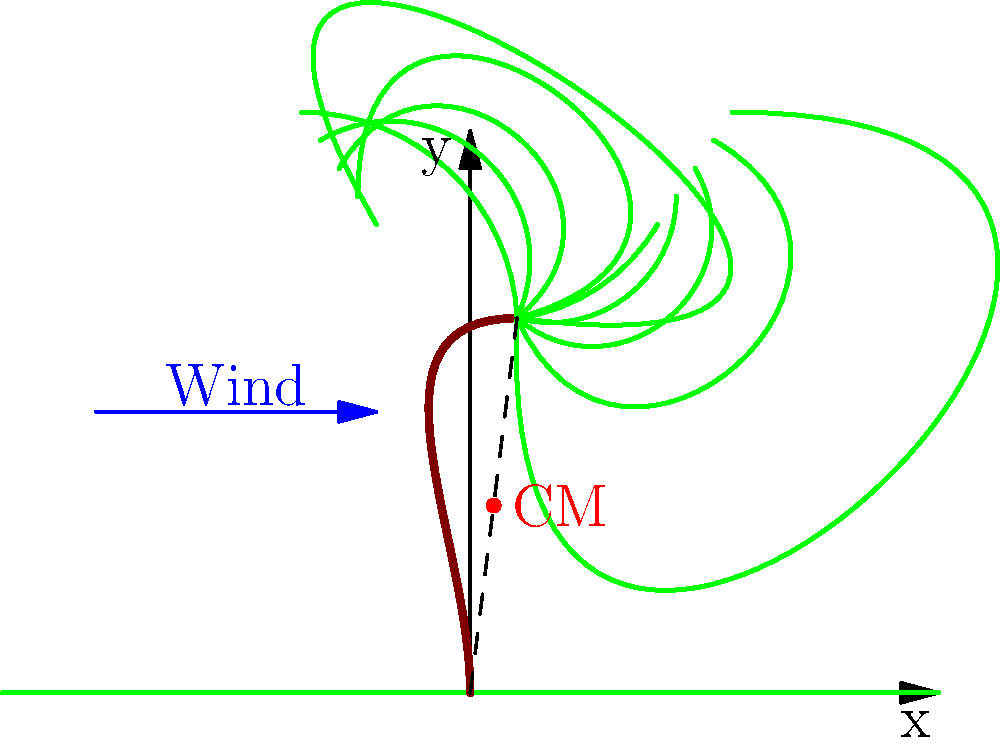A palm tree is swaying in the wind as shown in the diagram. How does the position of the center of mass (CM) change compared to its position when the tree is standing straight upright? Consider the effects on both the horizontal and vertical coordinates of the CM. To understand how the center of mass (CM) of the palm tree changes when it sways in the wind, let's analyze the situation step by step:

1. When the tree is upright:
   - The CM is located along the vertical axis of the trunk.
   - Its horizontal position is at $x = 0$.
   - Its vertical position is at some height $h$ above the ground.

2. When the tree sways:
   - The trunk bends, forming a curved shape.
   - The mass of the trunk and fronds is redistributed.

3. Horizontal change:
   - As the upper part of the tree moves to the right, some mass shifts in that direction.
   - This causes the CM to move slightly to the right.
   - The new horizontal position of the CM is $x > 0$.

4. Vertical change:
   - When the tree bends, its overall height decreases slightly.
   - The mass is now distributed over a shorter vertical distance.
   - This causes the CM to move slightly downward.
   - The new vertical position of the CM is $y < h$.

5. Overall movement:
   - The CM moves to a new position that is both to the right and lower than its original position.
   - The magnitude of this change depends on how much the tree sways and its flexibility.

6. Mathematical representation:
   - If we denote the original CM position as $(0, h)$ and the new position as $(x_{new}, y_{new})$, we can say:
     $x_{new} > 0$ and $y_{new} < h$

Therefore, when the palm tree sways in the wind, its center of mass moves to a position that is both to the right of and lower than its original position when the tree was standing straight upright.
Answer: The CM moves right and down. 